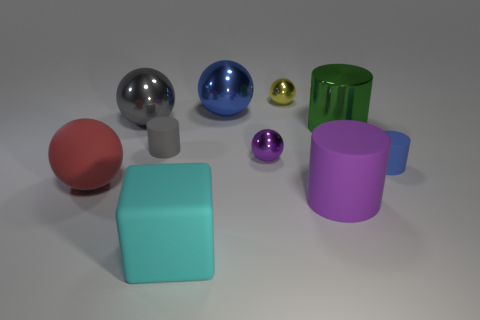How many blue things are both right of the tiny purple sphere and behind the gray cylinder?
Your answer should be very brief. 0. What color is the tiny matte cylinder in front of the tiny metal sphere that is in front of the tiny yellow object?
Ensure brevity in your answer.  Blue. What number of big cylinders are the same color as the large matte cube?
Your response must be concise. 0. There is a large rubber cube; is it the same color as the large thing that is behind the gray metallic thing?
Keep it short and to the point. No. Are there fewer things than tiny purple objects?
Offer a very short reply. No. Is the number of cylinders that are behind the yellow object greater than the number of big blue spheres that are behind the gray matte cylinder?
Your response must be concise. No. Do the blue cylinder and the yellow ball have the same material?
Your answer should be very brief. No. There is a small metal thing in front of the green thing; what number of large metal objects are left of it?
Provide a succinct answer. 2. There is a matte cylinder in front of the big red rubber object; does it have the same color as the block?
Offer a very short reply. No. What number of things are either large purple rubber things or small rubber things in front of the small gray thing?
Ensure brevity in your answer.  2. 